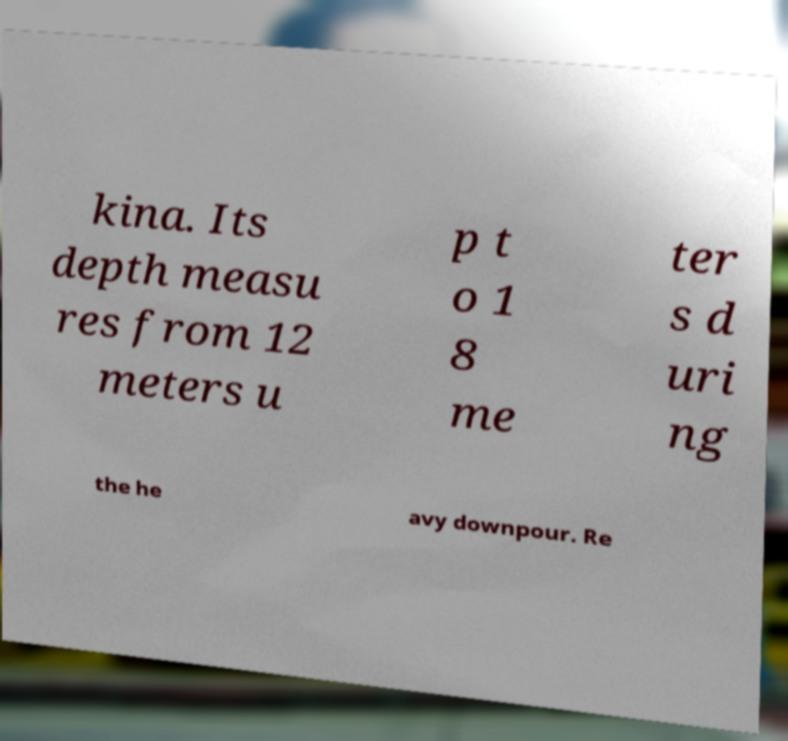Can you accurately transcribe the text from the provided image for me? kina. Its depth measu res from 12 meters u p t o 1 8 me ter s d uri ng the he avy downpour. Re 